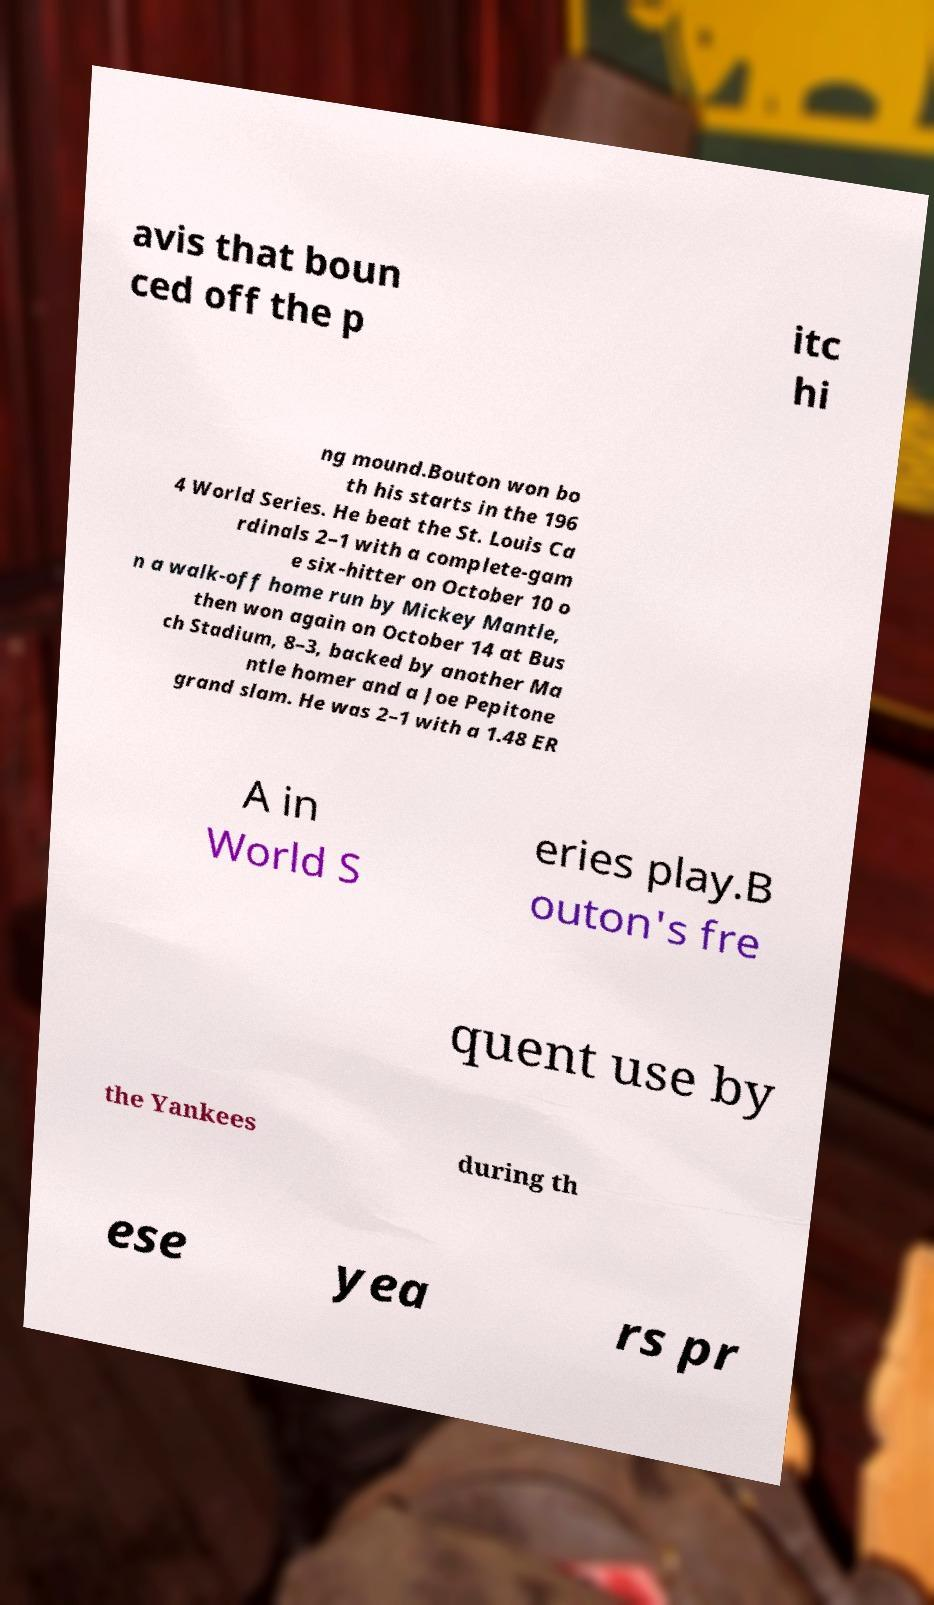Please identify and transcribe the text found in this image. avis that boun ced off the p itc hi ng mound.Bouton won bo th his starts in the 196 4 World Series. He beat the St. Louis Ca rdinals 2–1 with a complete-gam e six-hitter on October 10 o n a walk-off home run by Mickey Mantle, then won again on October 14 at Bus ch Stadium, 8–3, backed by another Ma ntle homer and a Joe Pepitone grand slam. He was 2–1 with a 1.48 ER A in World S eries play.B outon's fre quent use by the Yankees during th ese yea rs pr 